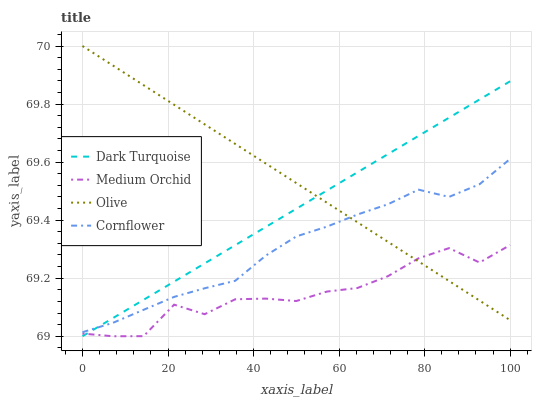Does Medium Orchid have the minimum area under the curve?
Answer yes or no. Yes. Does Olive have the maximum area under the curve?
Answer yes or no. Yes. Does Dark Turquoise have the minimum area under the curve?
Answer yes or no. No. Does Dark Turquoise have the maximum area under the curve?
Answer yes or no. No. Is Olive the smoothest?
Answer yes or no. Yes. Is Medium Orchid the roughest?
Answer yes or no. Yes. Is Dark Turquoise the smoothest?
Answer yes or no. No. Is Dark Turquoise the roughest?
Answer yes or no. No. Does Dark Turquoise have the lowest value?
Answer yes or no. Yes. Does Cornflower have the lowest value?
Answer yes or no. No. Does Olive have the highest value?
Answer yes or no. Yes. Does Dark Turquoise have the highest value?
Answer yes or no. No. Is Medium Orchid less than Cornflower?
Answer yes or no. Yes. Is Cornflower greater than Medium Orchid?
Answer yes or no. Yes. Does Olive intersect Medium Orchid?
Answer yes or no. Yes. Is Olive less than Medium Orchid?
Answer yes or no. No. Is Olive greater than Medium Orchid?
Answer yes or no. No. Does Medium Orchid intersect Cornflower?
Answer yes or no. No. 